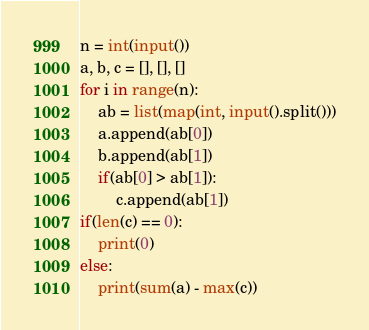Convert code to text. <code><loc_0><loc_0><loc_500><loc_500><_Python_>n = int(input())
a, b, c = [], [], []
for i in range(n):
    ab = list(map(int, input().split()))
    a.append(ab[0])
    b.append(ab[1])
    if(ab[0] > ab[1]):
        c.append(ab[1])
if(len(c) == 0):
    print(0)
else:
    print(sum(a) - max(c))</code> 